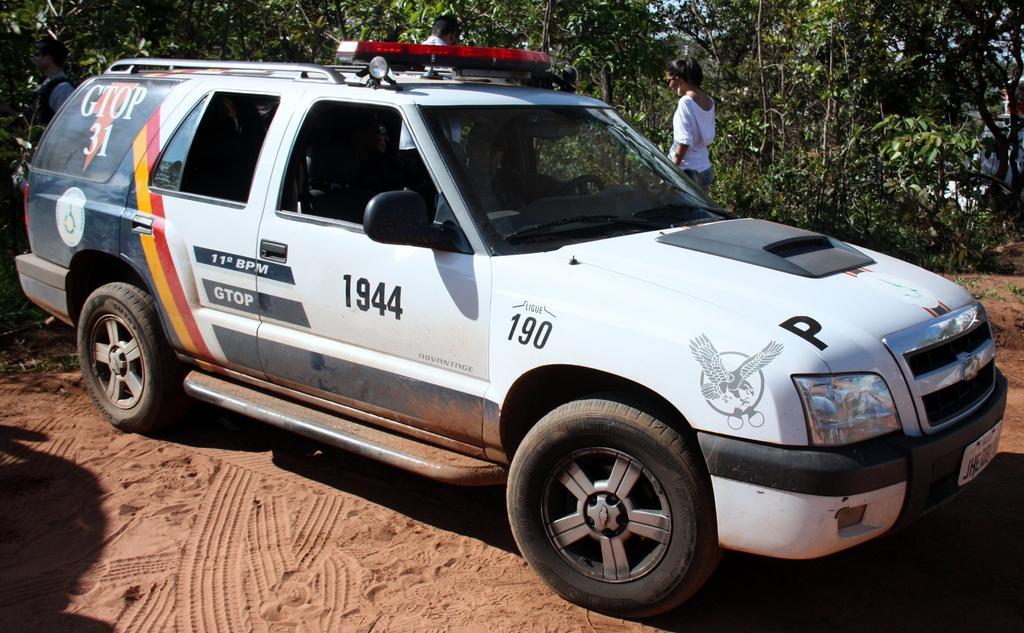Describe this image in one or two sentences. In the center of the image, we can see a vehicle on the ground and in the background, there are trees and we can see people. 